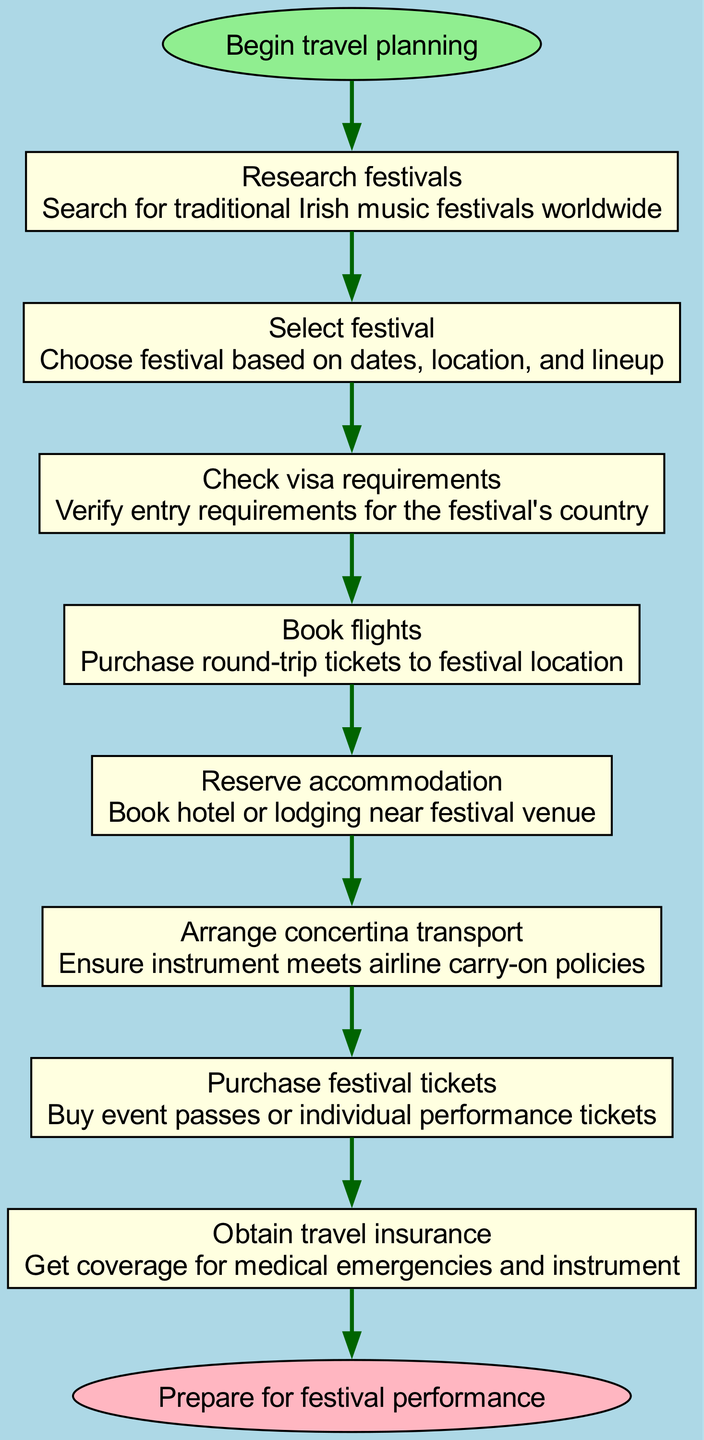What is the first step in the travel planning process? The flow chart indicates that the first step is "Research festivals." This is derived from the initial move from the "Begin travel planning" node to the first step node in the diagram.
Answer: Research festivals How many steps are involved in booking international travel? By counting the steps listed between the start and end nodes, there are eight distinct steps outlined for the travel planning process.
Answer: 8 What is the last step before preparing for the festival performance? The last step before reaching the "Prepare for festival performance" node is "Obtain travel insurance." This is identified as the final node before the end node in the flowchart.
Answer: Obtain travel insurance Which step involves ensuring the concertina meets airline policies? The step that addresses the transport of the concertina is "Arrange concertina transport," which connects from the previous steps and focuses on instrument travel requirements.
Answer: Arrange concertina transport What happens after selecting a festival? According to the flow chart, once a festival is selected, the next step is to "Check visa requirements." This sequence shows the direct relationship between these two nodes.
Answer: Check visa requirements Which step is directly connected to the "Book flights" step? The "Reserve accommodation" step is directly after "Book flights." It follows in sequence within the flow of the process shown in the diagram.
Answer: Reserve accommodation What is the main purpose of obtaining travel insurance? The main purpose of obtaining travel insurance is to "Get coverage for medical emergencies and instrument." This detail is explicitly stated in the information for that step.
Answer: Get coverage for medical emergencies and instrument How does the process begin and end? The process begins with "Begin travel planning" and ends with "Prepare for festival performance," showcasing the start and finish of the prescribed travel planning steps in the flowchart.
Answer: Begin travel planning and Prepare for festival performance 